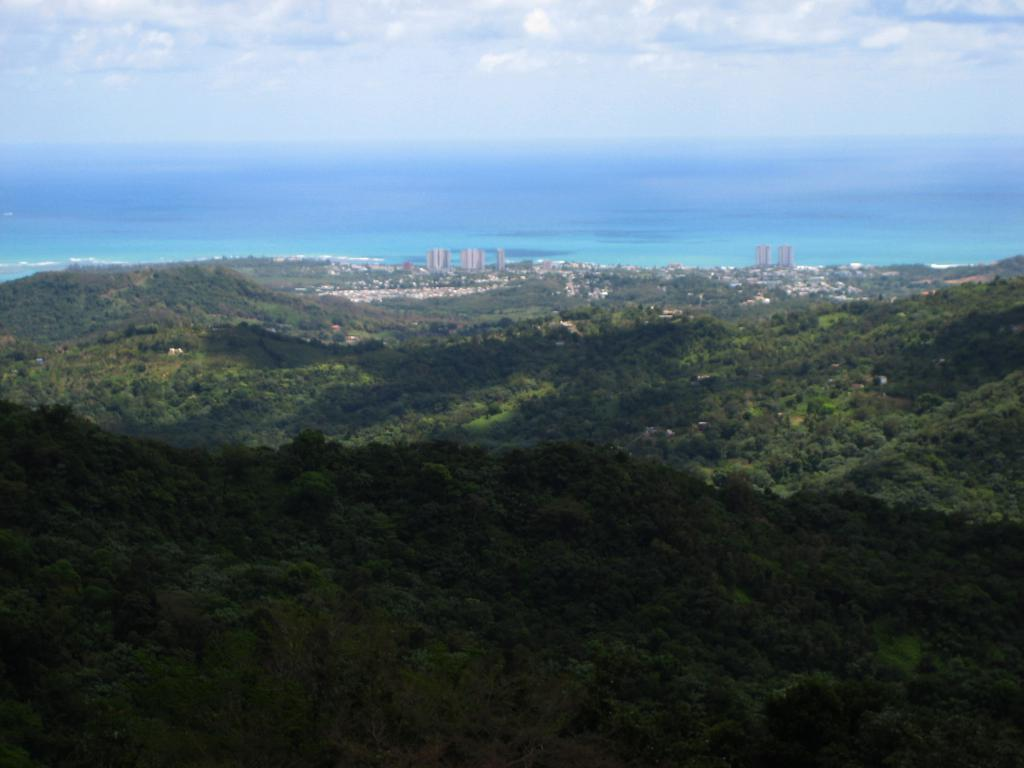What natural features are present in the foreground of the image? There are mountains and trees in the foreground of the image. What man-made feature can be seen in the foreground of the image? There is a city visible in the foreground of the image. What type of water body is visible in the foreground of the image? There is an ocean visible in the foreground of the image. What part of the natural environment is visible in the image? The sky is visible in the image. Where is the sofa located in the image? There is no sofa present in the image. What channel can be seen on the television in the image? There is no television present in the image. 